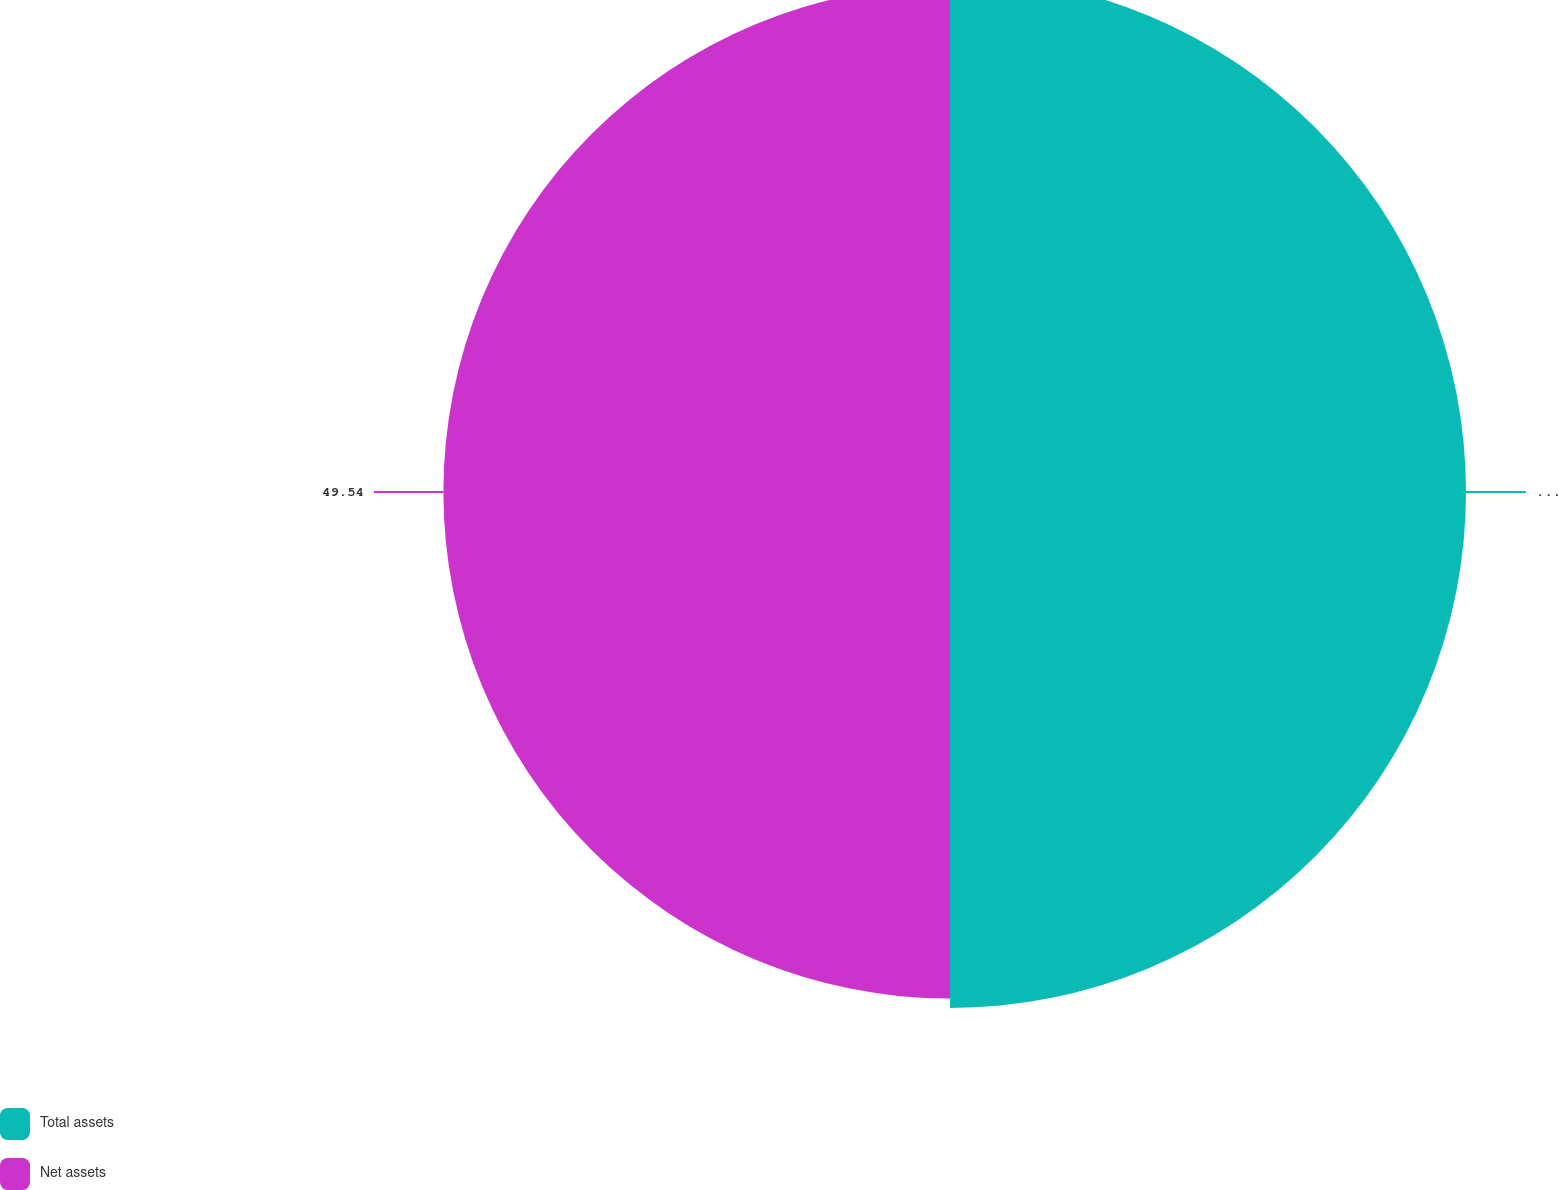Convert chart. <chart><loc_0><loc_0><loc_500><loc_500><pie_chart><fcel>Total assets<fcel>Net assets<nl><fcel>50.46%<fcel>49.54%<nl></chart> 